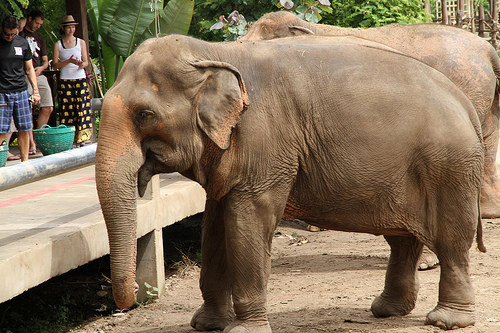Is the girl wearing a hat? No, the girl is not wearing a hat. 